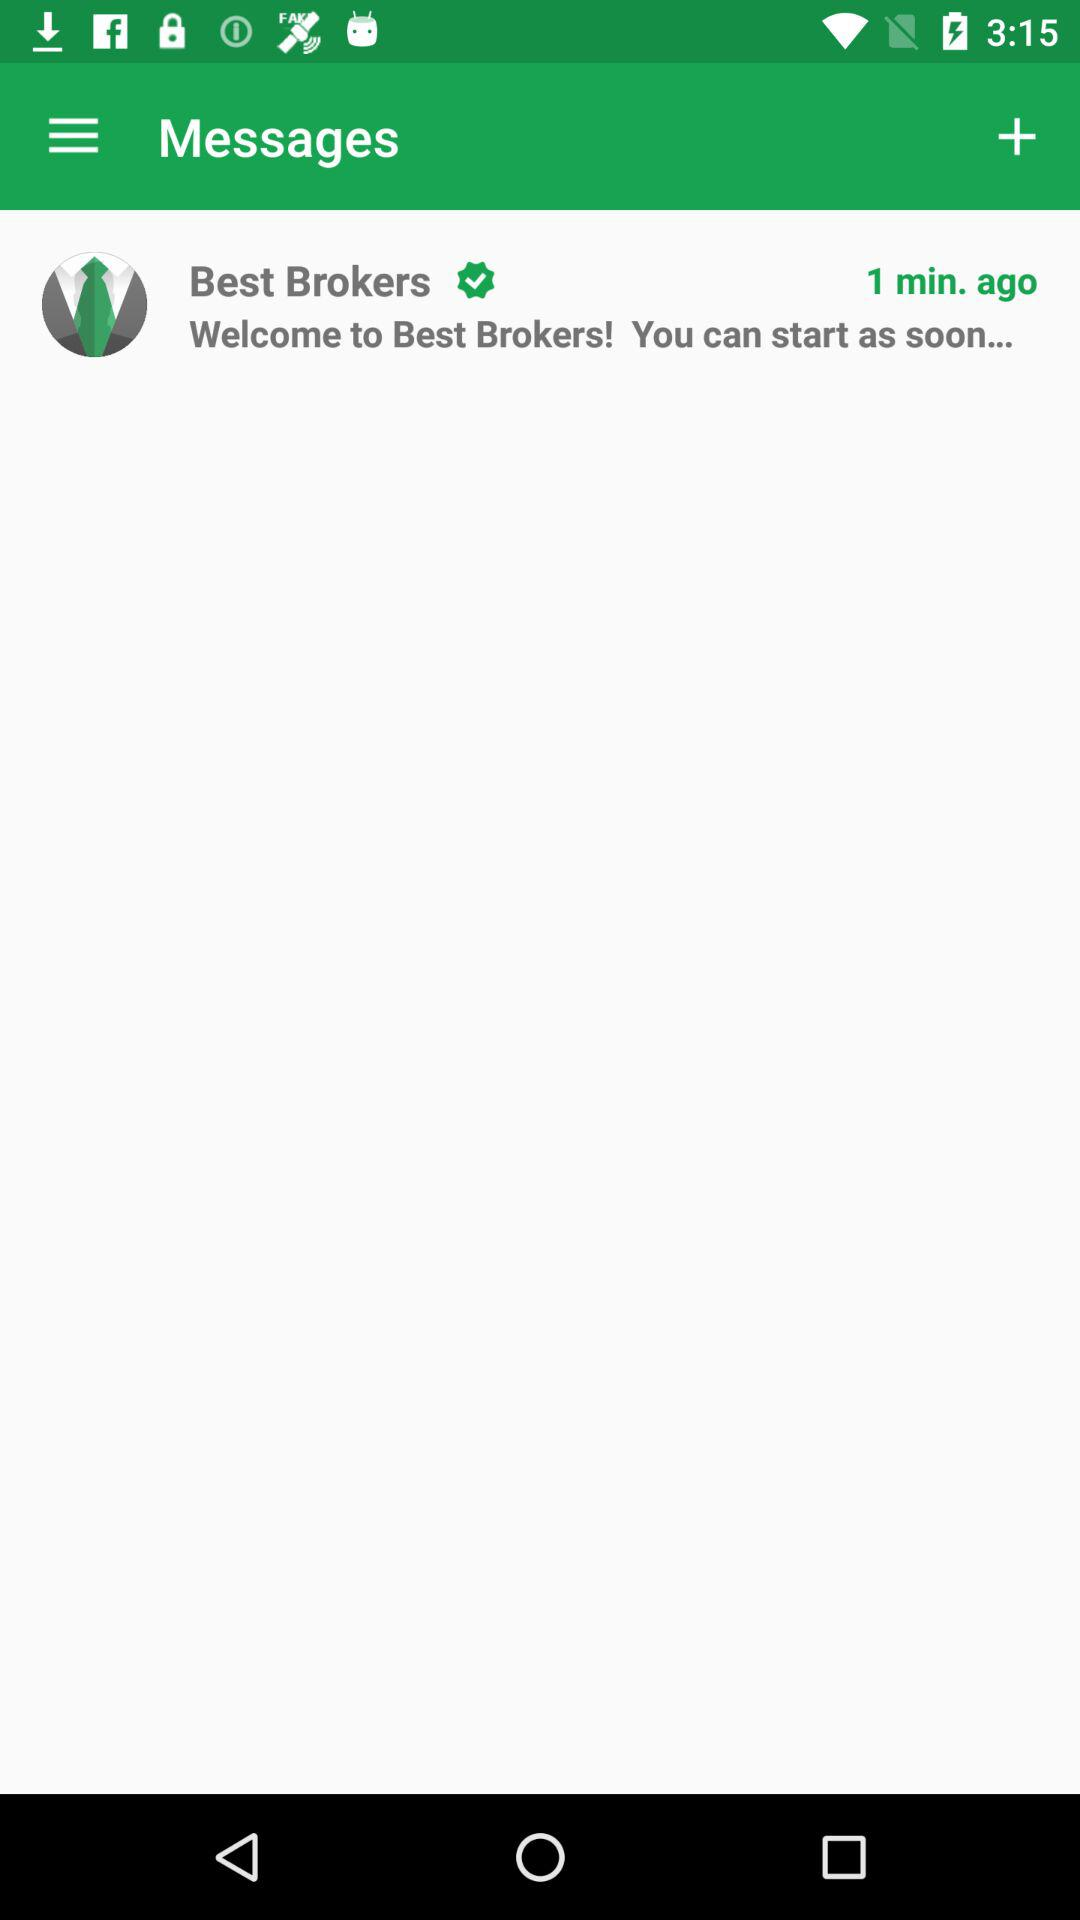When was the SMS received? The SMS was received 1 minute ago. 